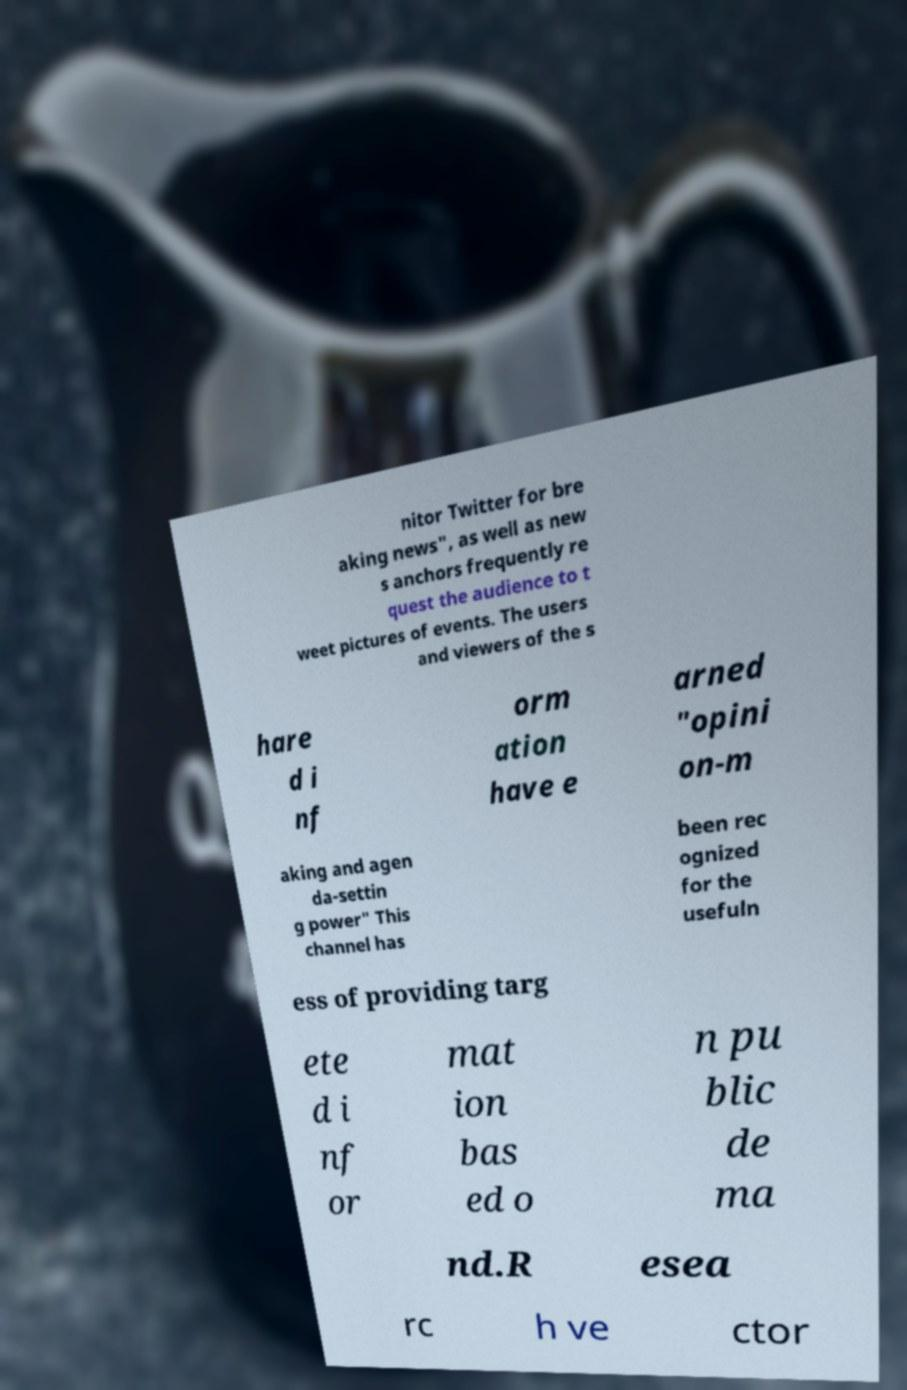Please read and relay the text visible in this image. What does it say? nitor Twitter for bre aking news", as well as new s anchors frequently re quest the audience to t weet pictures of events. The users and viewers of the s hare d i nf orm ation have e arned "opini on-m aking and agen da-settin g power" This channel has been rec ognized for the usefuln ess of providing targ ete d i nf or mat ion bas ed o n pu blic de ma nd.R esea rc h ve ctor 